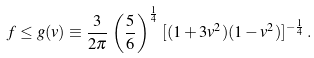Convert formula to latex. <formula><loc_0><loc_0><loc_500><loc_500>f \leq g ( v ) \equiv \frac { 3 } { 2 \pi } \, \left ( \frac { 5 } { 6 } \right ) ^ { \frac { 1 } { 4 } } \, [ ( 1 + 3 v ^ { 2 } ) ( 1 - v ^ { 2 } ) ] ^ { - \frac { 1 } { 4 } } \, .</formula> 